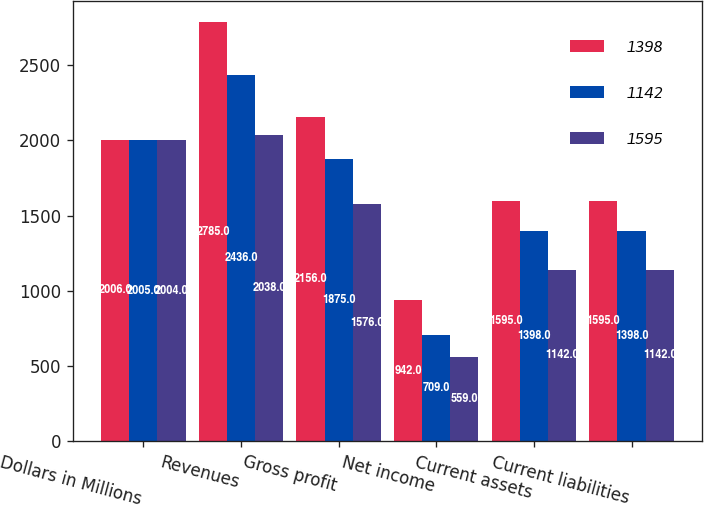Convert chart. <chart><loc_0><loc_0><loc_500><loc_500><stacked_bar_chart><ecel><fcel>Dollars in Millions<fcel>Revenues<fcel>Gross profit<fcel>Net income<fcel>Current assets<fcel>Current liabilities<nl><fcel>1398<fcel>2006<fcel>2785<fcel>2156<fcel>942<fcel>1595<fcel>1595<nl><fcel>1142<fcel>2005<fcel>2436<fcel>1875<fcel>709<fcel>1398<fcel>1398<nl><fcel>1595<fcel>2004<fcel>2038<fcel>1576<fcel>559<fcel>1142<fcel>1142<nl></chart> 